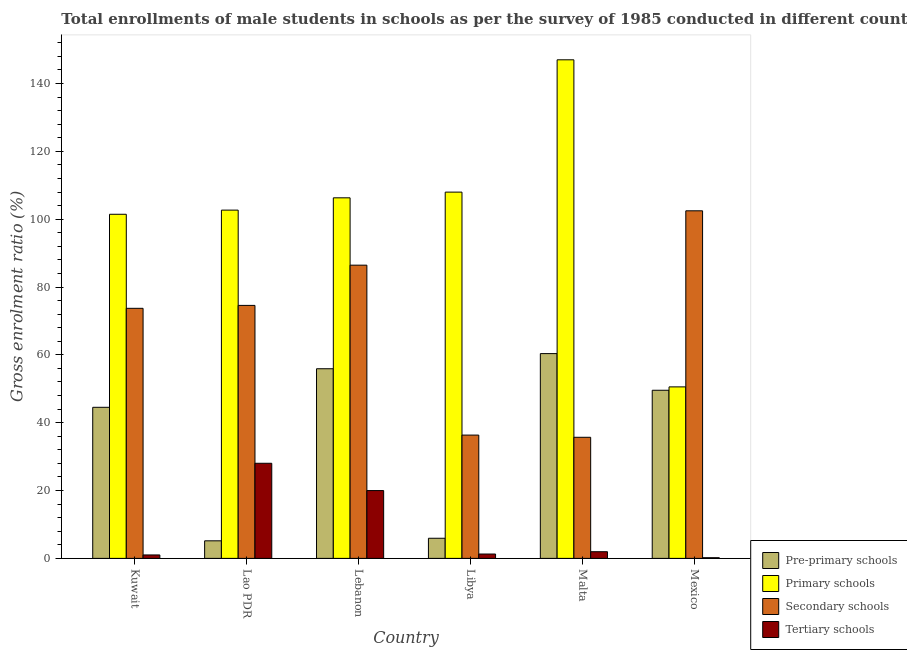Are the number of bars per tick equal to the number of legend labels?
Offer a terse response. Yes. How many bars are there on the 3rd tick from the left?
Your answer should be compact. 4. What is the label of the 2nd group of bars from the left?
Ensure brevity in your answer.  Lao PDR. What is the gross enrolment ratio(male) in primary schools in Mexico?
Ensure brevity in your answer.  50.56. Across all countries, what is the maximum gross enrolment ratio(male) in secondary schools?
Keep it short and to the point. 102.47. Across all countries, what is the minimum gross enrolment ratio(male) in primary schools?
Your answer should be compact. 50.56. In which country was the gross enrolment ratio(male) in pre-primary schools maximum?
Provide a succinct answer. Malta. What is the total gross enrolment ratio(male) in pre-primary schools in the graph?
Your answer should be compact. 221.49. What is the difference between the gross enrolment ratio(male) in secondary schools in Kuwait and that in Mexico?
Offer a terse response. -28.75. What is the difference between the gross enrolment ratio(male) in tertiary schools in Lao PDR and the gross enrolment ratio(male) in secondary schools in Kuwait?
Your answer should be very brief. -45.68. What is the average gross enrolment ratio(male) in pre-primary schools per country?
Provide a succinct answer. 36.91. What is the difference between the gross enrolment ratio(male) in tertiary schools and gross enrolment ratio(male) in secondary schools in Libya?
Your response must be concise. -35.06. In how many countries, is the gross enrolment ratio(male) in primary schools greater than 32 %?
Offer a terse response. 6. What is the ratio of the gross enrolment ratio(male) in secondary schools in Lebanon to that in Libya?
Offer a very short reply. 2.38. What is the difference between the highest and the second highest gross enrolment ratio(male) in secondary schools?
Your answer should be compact. 16.03. What is the difference between the highest and the lowest gross enrolment ratio(male) in secondary schools?
Offer a terse response. 66.77. In how many countries, is the gross enrolment ratio(male) in tertiary schools greater than the average gross enrolment ratio(male) in tertiary schools taken over all countries?
Make the answer very short. 2. Is the sum of the gross enrolment ratio(male) in secondary schools in Lao PDR and Mexico greater than the maximum gross enrolment ratio(male) in pre-primary schools across all countries?
Make the answer very short. Yes. What does the 2nd bar from the left in Lao PDR represents?
Your answer should be very brief. Primary schools. What does the 4th bar from the right in Mexico represents?
Make the answer very short. Pre-primary schools. Is it the case that in every country, the sum of the gross enrolment ratio(male) in pre-primary schools and gross enrolment ratio(male) in primary schools is greater than the gross enrolment ratio(male) in secondary schools?
Provide a short and direct response. No. How many bars are there?
Your answer should be very brief. 24. How many countries are there in the graph?
Give a very brief answer. 6. Are the values on the major ticks of Y-axis written in scientific E-notation?
Provide a succinct answer. No. Does the graph contain grids?
Make the answer very short. No. Where does the legend appear in the graph?
Provide a short and direct response. Bottom right. How many legend labels are there?
Ensure brevity in your answer.  4. What is the title of the graph?
Your answer should be very brief. Total enrollments of male students in schools as per the survey of 1985 conducted in different countries. What is the Gross enrolment ratio (%) in Pre-primary schools in Kuwait?
Your answer should be very brief. 44.54. What is the Gross enrolment ratio (%) of Primary schools in Kuwait?
Offer a very short reply. 101.44. What is the Gross enrolment ratio (%) of Secondary schools in Kuwait?
Offer a very short reply. 73.72. What is the Gross enrolment ratio (%) in Tertiary schools in Kuwait?
Your answer should be compact. 1.02. What is the Gross enrolment ratio (%) in Pre-primary schools in Lao PDR?
Offer a terse response. 5.18. What is the Gross enrolment ratio (%) of Primary schools in Lao PDR?
Offer a terse response. 102.67. What is the Gross enrolment ratio (%) in Secondary schools in Lao PDR?
Your answer should be very brief. 74.58. What is the Gross enrolment ratio (%) of Tertiary schools in Lao PDR?
Offer a terse response. 28.04. What is the Gross enrolment ratio (%) in Pre-primary schools in Lebanon?
Give a very brief answer. 55.91. What is the Gross enrolment ratio (%) of Primary schools in Lebanon?
Your answer should be compact. 106.29. What is the Gross enrolment ratio (%) in Secondary schools in Lebanon?
Ensure brevity in your answer.  86.44. What is the Gross enrolment ratio (%) in Tertiary schools in Lebanon?
Your answer should be compact. 19.99. What is the Gross enrolment ratio (%) in Pre-primary schools in Libya?
Provide a succinct answer. 5.93. What is the Gross enrolment ratio (%) in Primary schools in Libya?
Your answer should be very brief. 107.98. What is the Gross enrolment ratio (%) of Secondary schools in Libya?
Ensure brevity in your answer.  36.35. What is the Gross enrolment ratio (%) of Tertiary schools in Libya?
Your answer should be very brief. 1.28. What is the Gross enrolment ratio (%) of Pre-primary schools in Malta?
Ensure brevity in your answer.  60.37. What is the Gross enrolment ratio (%) of Primary schools in Malta?
Keep it short and to the point. 146.98. What is the Gross enrolment ratio (%) of Secondary schools in Malta?
Make the answer very short. 35.7. What is the Gross enrolment ratio (%) in Tertiary schools in Malta?
Provide a short and direct response. 1.97. What is the Gross enrolment ratio (%) in Pre-primary schools in Mexico?
Offer a terse response. 49.56. What is the Gross enrolment ratio (%) of Primary schools in Mexico?
Give a very brief answer. 50.56. What is the Gross enrolment ratio (%) of Secondary schools in Mexico?
Provide a short and direct response. 102.47. What is the Gross enrolment ratio (%) in Tertiary schools in Mexico?
Keep it short and to the point. 0.2. Across all countries, what is the maximum Gross enrolment ratio (%) in Pre-primary schools?
Your answer should be compact. 60.37. Across all countries, what is the maximum Gross enrolment ratio (%) of Primary schools?
Your response must be concise. 146.98. Across all countries, what is the maximum Gross enrolment ratio (%) of Secondary schools?
Offer a very short reply. 102.47. Across all countries, what is the maximum Gross enrolment ratio (%) of Tertiary schools?
Make the answer very short. 28.04. Across all countries, what is the minimum Gross enrolment ratio (%) of Pre-primary schools?
Make the answer very short. 5.18. Across all countries, what is the minimum Gross enrolment ratio (%) of Primary schools?
Give a very brief answer. 50.56. Across all countries, what is the minimum Gross enrolment ratio (%) in Secondary schools?
Make the answer very short. 35.7. Across all countries, what is the minimum Gross enrolment ratio (%) in Tertiary schools?
Your answer should be compact. 0.2. What is the total Gross enrolment ratio (%) of Pre-primary schools in the graph?
Ensure brevity in your answer.  221.49. What is the total Gross enrolment ratio (%) in Primary schools in the graph?
Provide a succinct answer. 615.92. What is the total Gross enrolment ratio (%) of Secondary schools in the graph?
Make the answer very short. 409.25. What is the total Gross enrolment ratio (%) in Tertiary schools in the graph?
Offer a terse response. 52.5. What is the difference between the Gross enrolment ratio (%) in Pre-primary schools in Kuwait and that in Lao PDR?
Provide a short and direct response. 39.36. What is the difference between the Gross enrolment ratio (%) in Primary schools in Kuwait and that in Lao PDR?
Offer a terse response. -1.23. What is the difference between the Gross enrolment ratio (%) in Secondary schools in Kuwait and that in Lao PDR?
Make the answer very short. -0.86. What is the difference between the Gross enrolment ratio (%) of Tertiary schools in Kuwait and that in Lao PDR?
Offer a terse response. -27.02. What is the difference between the Gross enrolment ratio (%) in Pre-primary schools in Kuwait and that in Lebanon?
Offer a terse response. -11.37. What is the difference between the Gross enrolment ratio (%) of Primary schools in Kuwait and that in Lebanon?
Ensure brevity in your answer.  -4.85. What is the difference between the Gross enrolment ratio (%) of Secondary schools in Kuwait and that in Lebanon?
Offer a terse response. -12.72. What is the difference between the Gross enrolment ratio (%) in Tertiary schools in Kuwait and that in Lebanon?
Offer a terse response. -18.98. What is the difference between the Gross enrolment ratio (%) in Pre-primary schools in Kuwait and that in Libya?
Provide a short and direct response. 38.61. What is the difference between the Gross enrolment ratio (%) of Primary schools in Kuwait and that in Libya?
Offer a terse response. -6.53. What is the difference between the Gross enrolment ratio (%) in Secondary schools in Kuwait and that in Libya?
Ensure brevity in your answer.  37.37. What is the difference between the Gross enrolment ratio (%) in Tertiary schools in Kuwait and that in Libya?
Offer a very short reply. -0.27. What is the difference between the Gross enrolment ratio (%) in Pre-primary schools in Kuwait and that in Malta?
Ensure brevity in your answer.  -15.83. What is the difference between the Gross enrolment ratio (%) in Primary schools in Kuwait and that in Malta?
Offer a terse response. -45.53. What is the difference between the Gross enrolment ratio (%) in Secondary schools in Kuwait and that in Malta?
Your response must be concise. 38.02. What is the difference between the Gross enrolment ratio (%) of Tertiary schools in Kuwait and that in Malta?
Your response must be concise. -0.95. What is the difference between the Gross enrolment ratio (%) in Pre-primary schools in Kuwait and that in Mexico?
Provide a succinct answer. -5.03. What is the difference between the Gross enrolment ratio (%) in Primary schools in Kuwait and that in Mexico?
Provide a succinct answer. 50.89. What is the difference between the Gross enrolment ratio (%) of Secondary schools in Kuwait and that in Mexico?
Provide a short and direct response. -28.75. What is the difference between the Gross enrolment ratio (%) in Tertiary schools in Kuwait and that in Mexico?
Ensure brevity in your answer.  0.82. What is the difference between the Gross enrolment ratio (%) of Pre-primary schools in Lao PDR and that in Lebanon?
Make the answer very short. -50.73. What is the difference between the Gross enrolment ratio (%) in Primary schools in Lao PDR and that in Lebanon?
Offer a terse response. -3.62. What is the difference between the Gross enrolment ratio (%) of Secondary schools in Lao PDR and that in Lebanon?
Your answer should be very brief. -11.86. What is the difference between the Gross enrolment ratio (%) of Tertiary schools in Lao PDR and that in Lebanon?
Offer a very short reply. 8.04. What is the difference between the Gross enrolment ratio (%) of Pre-primary schools in Lao PDR and that in Libya?
Provide a short and direct response. -0.75. What is the difference between the Gross enrolment ratio (%) of Primary schools in Lao PDR and that in Libya?
Your answer should be very brief. -5.3. What is the difference between the Gross enrolment ratio (%) of Secondary schools in Lao PDR and that in Libya?
Your answer should be compact. 38.23. What is the difference between the Gross enrolment ratio (%) in Tertiary schools in Lao PDR and that in Libya?
Provide a succinct answer. 26.75. What is the difference between the Gross enrolment ratio (%) of Pre-primary schools in Lao PDR and that in Malta?
Your answer should be compact. -55.19. What is the difference between the Gross enrolment ratio (%) in Primary schools in Lao PDR and that in Malta?
Make the answer very short. -44.31. What is the difference between the Gross enrolment ratio (%) in Secondary schools in Lao PDR and that in Malta?
Your answer should be compact. 38.88. What is the difference between the Gross enrolment ratio (%) in Tertiary schools in Lao PDR and that in Malta?
Provide a succinct answer. 26.07. What is the difference between the Gross enrolment ratio (%) in Pre-primary schools in Lao PDR and that in Mexico?
Give a very brief answer. -44.39. What is the difference between the Gross enrolment ratio (%) in Primary schools in Lao PDR and that in Mexico?
Your answer should be very brief. 52.11. What is the difference between the Gross enrolment ratio (%) of Secondary schools in Lao PDR and that in Mexico?
Give a very brief answer. -27.88. What is the difference between the Gross enrolment ratio (%) of Tertiary schools in Lao PDR and that in Mexico?
Your response must be concise. 27.84. What is the difference between the Gross enrolment ratio (%) of Pre-primary schools in Lebanon and that in Libya?
Provide a succinct answer. 49.97. What is the difference between the Gross enrolment ratio (%) in Primary schools in Lebanon and that in Libya?
Provide a short and direct response. -1.68. What is the difference between the Gross enrolment ratio (%) of Secondary schools in Lebanon and that in Libya?
Provide a succinct answer. 50.09. What is the difference between the Gross enrolment ratio (%) of Tertiary schools in Lebanon and that in Libya?
Your answer should be compact. 18.71. What is the difference between the Gross enrolment ratio (%) of Pre-primary schools in Lebanon and that in Malta?
Provide a short and direct response. -4.46. What is the difference between the Gross enrolment ratio (%) in Primary schools in Lebanon and that in Malta?
Your answer should be compact. -40.69. What is the difference between the Gross enrolment ratio (%) in Secondary schools in Lebanon and that in Malta?
Give a very brief answer. 50.74. What is the difference between the Gross enrolment ratio (%) in Tertiary schools in Lebanon and that in Malta?
Offer a terse response. 18.03. What is the difference between the Gross enrolment ratio (%) in Pre-primary schools in Lebanon and that in Mexico?
Your answer should be compact. 6.34. What is the difference between the Gross enrolment ratio (%) of Primary schools in Lebanon and that in Mexico?
Give a very brief answer. 55.73. What is the difference between the Gross enrolment ratio (%) of Secondary schools in Lebanon and that in Mexico?
Provide a succinct answer. -16.03. What is the difference between the Gross enrolment ratio (%) of Tertiary schools in Lebanon and that in Mexico?
Your answer should be very brief. 19.79. What is the difference between the Gross enrolment ratio (%) in Pre-primary schools in Libya and that in Malta?
Your response must be concise. -54.44. What is the difference between the Gross enrolment ratio (%) of Primary schools in Libya and that in Malta?
Keep it short and to the point. -39. What is the difference between the Gross enrolment ratio (%) of Secondary schools in Libya and that in Malta?
Make the answer very short. 0.65. What is the difference between the Gross enrolment ratio (%) of Tertiary schools in Libya and that in Malta?
Provide a succinct answer. -0.68. What is the difference between the Gross enrolment ratio (%) in Pre-primary schools in Libya and that in Mexico?
Your answer should be very brief. -43.63. What is the difference between the Gross enrolment ratio (%) in Primary schools in Libya and that in Mexico?
Give a very brief answer. 57.42. What is the difference between the Gross enrolment ratio (%) of Secondary schools in Libya and that in Mexico?
Your answer should be compact. -66.12. What is the difference between the Gross enrolment ratio (%) in Tertiary schools in Libya and that in Mexico?
Ensure brevity in your answer.  1.08. What is the difference between the Gross enrolment ratio (%) of Pre-primary schools in Malta and that in Mexico?
Provide a short and direct response. 10.81. What is the difference between the Gross enrolment ratio (%) of Primary schools in Malta and that in Mexico?
Give a very brief answer. 96.42. What is the difference between the Gross enrolment ratio (%) of Secondary schools in Malta and that in Mexico?
Your answer should be compact. -66.77. What is the difference between the Gross enrolment ratio (%) in Tertiary schools in Malta and that in Mexico?
Give a very brief answer. 1.77. What is the difference between the Gross enrolment ratio (%) in Pre-primary schools in Kuwait and the Gross enrolment ratio (%) in Primary schools in Lao PDR?
Ensure brevity in your answer.  -58.13. What is the difference between the Gross enrolment ratio (%) in Pre-primary schools in Kuwait and the Gross enrolment ratio (%) in Secondary schools in Lao PDR?
Offer a terse response. -30.04. What is the difference between the Gross enrolment ratio (%) of Pre-primary schools in Kuwait and the Gross enrolment ratio (%) of Tertiary schools in Lao PDR?
Offer a terse response. 16.5. What is the difference between the Gross enrolment ratio (%) in Primary schools in Kuwait and the Gross enrolment ratio (%) in Secondary schools in Lao PDR?
Offer a very short reply. 26.86. What is the difference between the Gross enrolment ratio (%) in Primary schools in Kuwait and the Gross enrolment ratio (%) in Tertiary schools in Lao PDR?
Ensure brevity in your answer.  73.41. What is the difference between the Gross enrolment ratio (%) of Secondary schools in Kuwait and the Gross enrolment ratio (%) of Tertiary schools in Lao PDR?
Ensure brevity in your answer.  45.68. What is the difference between the Gross enrolment ratio (%) in Pre-primary schools in Kuwait and the Gross enrolment ratio (%) in Primary schools in Lebanon?
Your response must be concise. -61.75. What is the difference between the Gross enrolment ratio (%) of Pre-primary schools in Kuwait and the Gross enrolment ratio (%) of Secondary schools in Lebanon?
Keep it short and to the point. -41.9. What is the difference between the Gross enrolment ratio (%) in Pre-primary schools in Kuwait and the Gross enrolment ratio (%) in Tertiary schools in Lebanon?
Ensure brevity in your answer.  24.54. What is the difference between the Gross enrolment ratio (%) of Primary schools in Kuwait and the Gross enrolment ratio (%) of Secondary schools in Lebanon?
Keep it short and to the point. 15.01. What is the difference between the Gross enrolment ratio (%) of Primary schools in Kuwait and the Gross enrolment ratio (%) of Tertiary schools in Lebanon?
Make the answer very short. 81.45. What is the difference between the Gross enrolment ratio (%) in Secondary schools in Kuwait and the Gross enrolment ratio (%) in Tertiary schools in Lebanon?
Your answer should be very brief. 53.72. What is the difference between the Gross enrolment ratio (%) of Pre-primary schools in Kuwait and the Gross enrolment ratio (%) of Primary schools in Libya?
Your response must be concise. -63.44. What is the difference between the Gross enrolment ratio (%) in Pre-primary schools in Kuwait and the Gross enrolment ratio (%) in Secondary schools in Libya?
Offer a terse response. 8.19. What is the difference between the Gross enrolment ratio (%) in Pre-primary schools in Kuwait and the Gross enrolment ratio (%) in Tertiary schools in Libya?
Your answer should be compact. 43.25. What is the difference between the Gross enrolment ratio (%) in Primary schools in Kuwait and the Gross enrolment ratio (%) in Secondary schools in Libya?
Ensure brevity in your answer.  65.1. What is the difference between the Gross enrolment ratio (%) in Primary schools in Kuwait and the Gross enrolment ratio (%) in Tertiary schools in Libya?
Give a very brief answer. 100.16. What is the difference between the Gross enrolment ratio (%) in Secondary schools in Kuwait and the Gross enrolment ratio (%) in Tertiary schools in Libya?
Ensure brevity in your answer.  72.43. What is the difference between the Gross enrolment ratio (%) of Pre-primary schools in Kuwait and the Gross enrolment ratio (%) of Primary schools in Malta?
Provide a short and direct response. -102.44. What is the difference between the Gross enrolment ratio (%) in Pre-primary schools in Kuwait and the Gross enrolment ratio (%) in Secondary schools in Malta?
Make the answer very short. 8.84. What is the difference between the Gross enrolment ratio (%) in Pre-primary schools in Kuwait and the Gross enrolment ratio (%) in Tertiary schools in Malta?
Keep it short and to the point. 42.57. What is the difference between the Gross enrolment ratio (%) in Primary schools in Kuwait and the Gross enrolment ratio (%) in Secondary schools in Malta?
Make the answer very short. 65.75. What is the difference between the Gross enrolment ratio (%) of Primary schools in Kuwait and the Gross enrolment ratio (%) of Tertiary schools in Malta?
Your response must be concise. 99.48. What is the difference between the Gross enrolment ratio (%) in Secondary schools in Kuwait and the Gross enrolment ratio (%) in Tertiary schools in Malta?
Provide a short and direct response. 71.75. What is the difference between the Gross enrolment ratio (%) of Pre-primary schools in Kuwait and the Gross enrolment ratio (%) of Primary schools in Mexico?
Offer a very short reply. -6.02. What is the difference between the Gross enrolment ratio (%) in Pre-primary schools in Kuwait and the Gross enrolment ratio (%) in Secondary schools in Mexico?
Offer a very short reply. -57.93. What is the difference between the Gross enrolment ratio (%) in Pre-primary schools in Kuwait and the Gross enrolment ratio (%) in Tertiary schools in Mexico?
Provide a short and direct response. 44.34. What is the difference between the Gross enrolment ratio (%) of Primary schools in Kuwait and the Gross enrolment ratio (%) of Secondary schools in Mexico?
Your answer should be compact. -1.02. What is the difference between the Gross enrolment ratio (%) of Primary schools in Kuwait and the Gross enrolment ratio (%) of Tertiary schools in Mexico?
Ensure brevity in your answer.  101.24. What is the difference between the Gross enrolment ratio (%) in Secondary schools in Kuwait and the Gross enrolment ratio (%) in Tertiary schools in Mexico?
Keep it short and to the point. 73.52. What is the difference between the Gross enrolment ratio (%) in Pre-primary schools in Lao PDR and the Gross enrolment ratio (%) in Primary schools in Lebanon?
Provide a short and direct response. -101.11. What is the difference between the Gross enrolment ratio (%) of Pre-primary schools in Lao PDR and the Gross enrolment ratio (%) of Secondary schools in Lebanon?
Your answer should be compact. -81.26. What is the difference between the Gross enrolment ratio (%) in Pre-primary schools in Lao PDR and the Gross enrolment ratio (%) in Tertiary schools in Lebanon?
Keep it short and to the point. -14.82. What is the difference between the Gross enrolment ratio (%) in Primary schools in Lao PDR and the Gross enrolment ratio (%) in Secondary schools in Lebanon?
Provide a short and direct response. 16.23. What is the difference between the Gross enrolment ratio (%) of Primary schools in Lao PDR and the Gross enrolment ratio (%) of Tertiary schools in Lebanon?
Provide a short and direct response. 82.68. What is the difference between the Gross enrolment ratio (%) of Secondary schools in Lao PDR and the Gross enrolment ratio (%) of Tertiary schools in Lebanon?
Provide a short and direct response. 54.59. What is the difference between the Gross enrolment ratio (%) of Pre-primary schools in Lao PDR and the Gross enrolment ratio (%) of Primary schools in Libya?
Keep it short and to the point. -102.8. What is the difference between the Gross enrolment ratio (%) of Pre-primary schools in Lao PDR and the Gross enrolment ratio (%) of Secondary schools in Libya?
Ensure brevity in your answer.  -31.17. What is the difference between the Gross enrolment ratio (%) in Pre-primary schools in Lao PDR and the Gross enrolment ratio (%) in Tertiary schools in Libya?
Your answer should be very brief. 3.89. What is the difference between the Gross enrolment ratio (%) of Primary schools in Lao PDR and the Gross enrolment ratio (%) of Secondary schools in Libya?
Keep it short and to the point. 66.32. What is the difference between the Gross enrolment ratio (%) in Primary schools in Lao PDR and the Gross enrolment ratio (%) in Tertiary schools in Libya?
Your response must be concise. 101.39. What is the difference between the Gross enrolment ratio (%) in Secondary schools in Lao PDR and the Gross enrolment ratio (%) in Tertiary schools in Libya?
Provide a succinct answer. 73.3. What is the difference between the Gross enrolment ratio (%) of Pre-primary schools in Lao PDR and the Gross enrolment ratio (%) of Primary schools in Malta?
Provide a short and direct response. -141.8. What is the difference between the Gross enrolment ratio (%) of Pre-primary schools in Lao PDR and the Gross enrolment ratio (%) of Secondary schools in Malta?
Ensure brevity in your answer.  -30.52. What is the difference between the Gross enrolment ratio (%) in Pre-primary schools in Lao PDR and the Gross enrolment ratio (%) in Tertiary schools in Malta?
Offer a very short reply. 3.21. What is the difference between the Gross enrolment ratio (%) of Primary schools in Lao PDR and the Gross enrolment ratio (%) of Secondary schools in Malta?
Offer a terse response. 66.97. What is the difference between the Gross enrolment ratio (%) of Primary schools in Lao PDR and the Gross enrolment ratio (%) of Tertiary schools in Malta?
Make the answer very short. 100.7. What is the difference between the Gross enrolment ratio (%) of Secondary schools in Lao PDR and the Gross enrolment ratio (%) of Tertiary schools in Malta?
Provide a succinct answer. 72.61. What is the difference between the Gross enrolment ratio (%) in Pre-primary schools in Lao PDR and the Gross enrolment ratio (%) in Primary schools in Mexico?
Your response must be concise. -45.38. What is the difference between the Gross enrolment ratio (%) of Pre-primary schools in Lao PDR and the Gross enrolment ratio (%) of Secondary schools in Mexico?
Offer a terse response. -97.29. What is the difference between the Gross enrolment ratio (%) in Pre-primary schools in Lao PDR and the Gross enrolment ratio (%) in Tertiary schools in Mexico?
Offer a terse response. 4.98. What is the difference between the Gross enrolment ratio (%) of Primary schools in Lao PDR and the Gross enrolment ratio (%) of Secondary schools in Mexico?
Your response must be concise. 0.2. What is the difference between the Gross enrolment ratio (%) in Primary schools in Lao PDR and the Gross enrolment ratio (%) in Tertiary schools in Mexico?
Give a very brief answer. 102.47. What is the difference between the Gross enrolment ratio (%) in Secondary schools in Lao PDR and the Gross enrolment ratio (%) in Tertiary schools in Mexico?
Your response must be concise. 74.38. What is the difference between the Gross enrolment ratio (%) of Pre-primary schools in Lebanon and the Gross enrolment ratio (%) of Primary schools in Libya?
Your response must be concise. -52.07. What is the difference between the Gross enrolment ratio (%) of Pre-primary schools in Lebanon and the Gross enrolment ratio (%) of Secondary schools in Libya?
Your answer should be very brief. 19.56. What is the difference between the Gross enrolment ratio (%) in Pre-primary schools in Lebanon and the Gross enrolment ratio (%) in Tertiary schools in Libya?
Your answer should be very brief. 54.62. What is the difference between the Gross enrolment ratio (%) in Primary schools in Lebanon and the Gross enrolment ratio (%) in Secondary schools in Libya?
Ensure brevity in your answer.  69.94. What is the difference between the Gross enrolment ratio (%) in Primary schools in Lebanon and the Gross enrolment ratio (%) in Tertiary schools in Libya?
Provide a succinct answer. 105.01. What is the difference between the Gross enrolment ratio (%) of Secondary schools in Lebanon and the Gross enrolment ratio (%) of Tertiary schools in Libya?
Make the answer very short. 85.15. What is the difference between the Gross enrolment ratio (%) of Pre-primary schools in Lebanon and the Gross enrolment ratio (%) of Primary schools in Malta?
Ensure brevity in your answer.  -91.07. What is the difference between the Gross enrolment ratio (%) in Pre-primary schools in Lebanon and the Gross enrolment ratio (%) in Secondary schools in Malta?
Keep it short and to the point. 20.21. What is the difference between the Gross enrolment ratio (%) in Pre-primary schools in Lebanon and the Gross enrolment ratio (%) in Tertiary schools in Malta?
Your answer should be compact. 53.94. What is the difference between the Gross enrolment ratio (%) of Primary schools in Lebanon and the Gross enrolment ratio (%) of Secondary schools in Malta?
Your answer should be very brief. 70.59. What is the difference between the Gross enrolment ratio (%) in Primary schools in Lebanon and the Gross enrolment ratio (%) in Tertiary schools in Malta?
Give a very brief answer. 104.32. What is the difference between the Gross enrolment ratio (%) of Secondary schools in Lebanon and the Gross enrolment ratio (%) of Tertiary schools in Malta?
Your answer should be very brief. 84.47. What is the difference between the Gross enrolment ratio (%) in Pre-primary schools in Lebanon and the Gross enrolment ratio (%) in Primary schools in Mexico?
Make the answer very short. 5.35. What is the difference between the Gross enrolment ratio (%) in Pre-primary schools in Lebanon and the Gross enrolment ratio (%) in Secondary schools in Mexico?
Offer a terse response. -46.56. What is the difference between the Gross enrolment ratio (%) in Pre-primary schools in Lebanon and the Gross enrolment ratio (%) in Tertiary schools in Mexico?
Your response must be concise. 55.71. What is the difference between the Gross enrolment ratio (%) of Primary schools in Lebanon and the Gross enrolment ratio (%) of Secondary schools in Mexico?
Your response must be concise. 3.83. What is the difference between the Gross enrolment ratio (%) in Primary schools in Lebanon and the Gross enrolment ratio (%) in Tertiary schools in Mexico?
Offer a very short reply. 106.09. What is the difference between the Gross enrolment ratio (%) of Secondary schools in Lebanon and the Gross enrolment ratio (%) of Tertiary schools in Mexico?
Offer a very short reply. 86.24. What is the difference between the Gross enrolment ratio (%) of Pre-primary schools in Libya and the Gross enrolment ratio (%) of Primary schools in Malta?
Offer a very short reply. -141.05. What is the difference between the Gross enrolment ratio (%) in Pre-primary schools in Libya and the Gross enrolment ratio (%) in Secondary schools in Malta?
Your answer should be very brief. -29.77. What is the difference between the Gross enrolment ratio (%) of Pre-primary schools in Libya and the Gross enrolment ratio (%) of Tertiary schools in Malta?
Keep it short and to the point. 3.97. What is the difference between the Gross enrolment ratio (%) in Primary schools in Libya and the Gross enrolment ratio (%) in Secondary schools in Malta?
Give a very brief answer. 72.28. What is the difference between the Gross enrolment ratio (%) of Primary schools in Libya and the Gross enrolment ratio (%) of Tertiary schools in Malta?
Provide a short and direct response. 106.01. What is the difference between the Gross enrolment ratio (%) of Secondary schools in Libya and the Gross enrolment ratio (%) of Tertiary schools in Malta?
Offer a very short reply. 34.38. What is the difference between the Gross enrolment ratio (%) in Pre-primary schools in Libya and the Gross enrolment ratio (%) in Primary schools in Mexico?
Ensure brevity in your answer.  -44.62. What is the difference between the Gross enrolment ratio (%) in Pre-primary schools in Libya and the Gross enrolment ratio (%) in Secondary schools in Mexico?
Your answer should be very brief. -96.53. What is the difference between the Gross enrolment ratio (%) in Pre-primary schools in Libya and the Gross enrolment ratio (%) in Tertiary schools in Mexico?
Ensure brevity in your answer.  5.73. What is the difference between the Gross enrolment ratio (%) of Primary schools in Libya and the Gross enrolment ratio (%) of Secondary schools in Mexico?
Offer a very short reply. 5.51. What is the difference between the Gross enrolment ratio (%) of Primary schools in Libya and the Gross enrolment ratio (%) of Tertiary schools in Mexico?
Provide a short and direct response. 107.78. What is the difference between the Gross enrolment ratio (%) in Secondary schools in Libya and the Gross enrolment ratio (%) in Tertiary schools in Mexico?
Offer a terse response. 36.15. What is the difference between the Gross enrolment ratio (%) in Pre-primary schools in Malta and the Gross enrolment ratio (%) in Primary schools in Mexico?
Your response must be concise. 9.81. What is the difference between the Gross enrolment ratio (%) of Pre-primary schools in Malta and the Gross enrolment ratio (%) of Secondary schools in Mexico?
Offer a very short reply. -42.1. What is the difference between the Gross enrolment ratio (%) of Pre-primary schools in Malta and the Gross enrolment ratio (%) of Tertiary schools in Mexico?
Keep it short and to the point. 60.17. What is the difference between the Gross enrolment ratio (%) of Primary schools in Malta and the Gross enrolment ratio (%) of Secondary schools in Mexico?
Make the answer very short. 44.51. What is the difference between the Gross enrolment ratio (%) of Primary schools in Malta and the Gross enrolment ratio (%) of Tertiary schools in Mexico?
Your answer should be compact. 146.78. What is the difference between the Gross enrolment ratio (%) of Secondary schools in Malta and the Gross enrolment ratio (%) of Tertiary schools in Mexico?
Offer a very short reply. 35.5. What is the average Gross enrolment ratio (%) of Pre-primary schools per country?
Provide a short and direct response. 36.91. What is the average Gross enrolment ratio (%) of Primary schools per country?
Your response must be concise. 102.65. What is the average Gross enrolment ratio (%) of Secondary schools per country?
Keep it short and to the point. 68.21. What is the average Gross enrolment ratio (%) in Tertiary schools per country?
Keep it short and to the point. 8.75. What is the difference between the Gross enrolment ratio (%) in Pre-primary schools and Gross enrolment ratio (%) in Primary schools in Kuwait?
Your answer should be very brief. -56.91. What is the difference between the Gross enrolment ratio (%) of Pre-primary schools and Gross enrolment ratio (%) of Secondary schools in Kuwait?
Your response must be concise. -29.18. What is the difference between the Gross enrolment ratio (%) of Pre-primary schools and Gross enrolment ratio (%) of Tertiary schools in Kuwait?
Offer a very short reply. 43.52. What is the difference between the Gross enrolment ratio (%) of Primary schools and Gross enrolment ratio (%) of Secondary schools in Kuwait?
Provide a succinct answer. 27.73. What is the difference between the Gross enrolment ratio (%) in Primary schools and Gross enrolment ratio (%) in Tertiary schools in Kuwait?
Ensure brevity in your answer.  100.43. What is the difference between the Gross enrolment ratio (%) in Secondary schools and Gross enrolment ratio (%) in Tertiary schools in Kuwait?
Ensure brevity in your answer.  72.7. What is the difference between the Gross enrolment ratio (%) of Pre-primary schools and Gross enrolment ratio (%) of Primary schools in Lao PDR?
Make the answer very short. -97.49. What is the difference between the Gross enrolment ratio (%) of Pre-primary schools and Gross enrolment ratio (%) of Secondary schools in Lao PDR?
Your response must be concise. -69.4. What is the difference between the Gross enrolment ratio (%) in Pre-primary schools and Gross enrolment ratio (%) in Tertiary schools in Lao PDR?
Ensure brevity in your answer.  -22.86. What is the difference between the Gross enrolment ratio (%) in Primary schools and Gross enrolment ratio (%) in Secondary schools in Lao PDR?
Offer a terse response. 28.09. What is the difference between the Gross enrolment ratio (%) of Primary schools and Gross enrolment ratio (%) of Tertiary schools in Lao PDR?
Provide a short and direct response. 74.63. What is the difference between the Gross enrolment ratio (%) in Secondary schools and Gross enrolment ratio (%) in Tertiary schools in Lao PDR?
Offer a very short reply. 46.54. What is the difference between the Gross enrolment ratio (%) of Pre-primary schools and Gross enrolment ratio (%) of Primary schools in Lebanon?
Your answer should be very brief. -50.39. What is the difference between the Gross enrolment ratio (%) of Pre-primary schools and Gross enrolment ratio (%) of Secondary schools in Lebanon?
Your answer should be compact. -30.53. What is the difference between the Gross enrolment ratio (%) of Pre-primary schools and Gross enrolment ratio (%) of Tertiary schools in Lebanon?
Provide a short and direct response. 35.91. What is the difference between the Gross enrolment ratio (%) in Primary schools and Gross enrolment ratio (%) in Secondary schools in Lebanon?
Your answer should be very brief. 19.85. What is the difference between the Gross enrolment ratio (%) in Primary schools and Gross enrolment ratio (%) in Tertiary schools in Lebanon?
Give a very brief answer. 86.3. What is the difference between the Gross enrolment ratio (%) in Secondary schools and Gross enrolment ratio (%) in Tertiary schools in Lebanon?
Make the answer very short. 66.45. What is the difference between the Gross enrolment ratio (%) of Pre-primary schools and Gross enrolment ratio (%) of Primary schools in Libya?
Keep it short and to the point. -102.04. What is the difference between the Gross enrolment ratio (%) of Pre-primary schools and Gross enrolment ratio (%) of Secondary schools in Libya?
Provide a short and direct response. -30.42. What is the difference between the Gross enrolment ratio (%) in Pre-primary schools and Gross enrolment ratio (%) in Tertiary schools in Libya?
Give a very brief answer. 4.65. What is the difference between the Gross enrolment ratio (%) of Primary schools and Gross enrolment ratio (%) of Secondary schools in Libya?
Offer a very short reply. 71.63. What is the difference between the Gross enrolment ratio (%) of Primary schools and Gross enrolment ratio (%) of Tertiary schools in Libya?
Your answer should be very brief. 106.69. What is the difference between the Gross enrolment ratio (%) in Secondary schools and Gross enrolment ratio (%) in Tertiary schools in Libya?
Your answer should be very brief. 35.06. What is the difference between the Gross enrolment ratio (%) of Pre-primary schools and Gross enrolment ratio (%) of Primary schools in Malta?
Make the answer very short. -86.61. What is the difference between the Gross enrolment ratio (%) in Pre-primary schools and Gross enrolment ratio (%) in Secondary schools in Malta?
Your response must be concise. 24.67. What is the difference between the Gross enrolment ratio (%) in Pre-primary schools and Gross enrolment ratio (%) in Tertiary schools in Malta?
Make the answer very short. 58.4. What is the difference between the Gross enrolment ratio (%) of Primary schools and Gross enrolment ratio (%) of Secondary schools in Malta?
Provide a short and direct response. 111.28. What is the difference between the Gross enrolment ratio (%) in Primary schools and Gross enrolment ratio (%) in Tertiary schools in Malta?
Offer a very short reply. 145.01. What is the difference between the Gross enrolment ratio (%) in Secondary schools and Gross enrolment ratio (%) in Tertiary schools in Malta?
Ensure brevity in your answer.  33.73. What is the difference between the Gross enrolment ratio (%) of Pre-primary schools and Gross enrolment ratio (%) of Primary schools in Mexico?
Offer a very short reply. -0.99. What is the difference between the Gross enrolment ratio (%) of Pre-primary schools and Gross enrolment ratio (%) of Secondary schools in Mexico?
Your response must be concise. -52.9. What is the difference between the Gross enrolment ratio (%) of Pre-primary schools and Gross enrolment ratio (%) of Tertiary schools in Mexico?
Your answer should be compact. 49.36. What is the difference between the Gross enrolment ratio (%) of Primary schools and Gross enrolment ratio (%) of Secondary schools in Mexico?
Offer a terse response. -51.91. What is the difference between the Gross enrolment ratio (%) of Primary schools and Gross enrolment ratio (%) of Tertiary schools in Mexico?
Keep it short and to the point. 50.36. What is the difference between the Gross enrolment ratio (%) in Secondary schools and Gross enrolment ratio (%) in Tertiary schools in Mexico?
Offer a terse response. 102.27. What is the ratio of the Gross enrolment ratio (%) in Pre-primary schools in Kuwait to that in Lao PDR?
Provide a short and direct response. 8.6. What is the ratio of the Gross enrolment ratio (%) in Secondary schools in Kuwait to that in Lao PDR?
Offer a terse response. 0.99. What is the ratio of the Gross enrolment ratio (%) in Tertiary schools in Kuwait to that in Lao PDR?
Provide a short and direct response. 0.04. What is the ratio of the Gross enrolment ratio (%) in Pre-primary schools in Kuwait to that in Lebanon?
Give a very brief answer. 0.8. What is the ratio of the Gross enrolment ratio (%) of Primary schools in Kuwait to that in Lebanon?
Give a very brief answer. 0.95. What is the ratio of the Gross enrolment ratio (%) of Secondary schools in Kuwait to that in Lebanon?
Provide a succinct answer. 0.85. What is the ratio of the Gross enrolment ratio (%) in Tertiary schools in Kuwait to that in Lebanon?
Give a very brief answer. 0.05. What is the ratio of the Gross enrolment ratio (%) of Pre-primary schools in Kuwait to that in Libya?
Your response must be concise. 7.51. What is the ratio of the Gross enrolment ratio (%) of Primary schools in Kuwait to that in Libya?
Offer a very short reply. 0.94. What is the ratio of the Gross enrolment ratio (%) of Secondary schools in Kuwait to that in Libya?
Offer a very short reply. 2.03. What is the ratio of the Gross enrolment ratio (%) of Tertiary schools in Kuwait to that in Libya?
Offer a terse response. 0.79. What is the ratio of the Gross enrolment ratio (%) in Pre-primary schools in Kuwait to that in Malta?
Make the answer very short. 0.74. What is the ratio of the Gross enrolment ratio (%) of Primary schools in Kuwait to that in Malta?
Give a very brief answer. 0.69. What is the ratio of the Gross enrolment ratio (%) in Secondary schools in Kuwait to that in Malta?
Offer a terse response. 2.06. What is the ratio of the Gross enrolment ratio (%) in Tertiary schools in Kuwait to that in Malta?
Your answer should be very brief. 0.52. What is the ratio of the Gross enrolment ratio (%) of Pre-primary schools in Kuwait to that in Mexico?
Your answer should be compact. 0.9. What is the ratio of the Gross enrolment ratio (%) in Primary schools in Kuwait to that in Mexico?
Offer a terse response. 2.01. What is the ratio of the Gross enrolment ratio (%) in Secondary schools in Kuwait to that in Mexico?
Offer a very short reply. 0.72. What is the ratio of the Gross enrolment ratio (%) in Tertiary schools in Kuwait to that in Mexico?
Your answer should be compact. 5.08. What is the ratio of the Gross enrolment ratio (%) in Pre-primary schools in Lao PDR to that in Lebanon?
Provide a short and direct response. 0.09. What is the ratio of the Gross enrolment ratio (%) of Primary schools in Lao PDR to that in Lebanon?
Offer a terse response. 0.97. What is the ratio of the Gross enrolment ratio (%) in Secondary schools in Lao PDR to that in Lebanon?
Make the answer very short. 0.86. What is the ratio of the Gross enrolment ratio (%) of Tertiary schools in Lao PDR to that in Lebanon?
Provide a short and direct response. 1.4. What is the ratio of the Gross enrolment ratio (%) of Pre-primary schools in Lao PDR to that in Libya?
Offer a very short reply. 0.87. What is the ratio of the Gross enrolment ratio (%) of Primary schools in Lao PDR to that in Libya?
Your answer should be very brief. 0.95. What is the ratio of the Gross enrolment ratio (%) of Secondary schools in Lao PDR to that in Libya?
Ensure brevity in your answer.  2.05. What is the ratio of the Gross enrolment ratio (%) of Tertiary schools in Lao PDR to that in Libya?
Make the answer very short. 21.82. What is the ratio of the Gross enrolment ratio (%) of Pre-primary schools in Lao PDR to that in Malta?
Your response must be concise. 0.09. What is the ratio of the Gross enrolment ratio (%) of Primary schools in Lao PDR to that in Malta?
Offer a very short reply. 0.7. What is the ratio of the Gross enrolment ratio (%) in Secondary schools in Lao PDR to that in Malta?
Ensure brevity in your answer.  2.09. What is the ratio of the Gross enrolment ratio (%) of Tertiary schools in Lao PDR to that in Malta?
Your answer should be very brief. 14.26. What is the ratio of the Gross enrolment ratio (%) in Pre-primary schools in Lao PDR to that in Mexico?
Your response must be concise. 0.1. What is the ratio of the Gross enrolment ratio (%) in Primary schools in Lao PDR to that in Mexico?
Offer a very short reply. 2.03. What is the ratio of the Gross enrolment ratio (%) of Secondary schools in Lao PDR to that in Mexico?
Keep it short and to the point. 0.73. What is the ratio of the Gross enrolment ratio (%) of Tertiary schools in Lao PDR to that in Mexico?
Keep it short and to the point. 140.11. What is the ratio of the Gross enrolment ratio (%) in Pre-primary schools in Lebanon to that in Libya?
Offer a very short reply. 9.42. What is the ratio of the Gross enrolment ratio (%) of Primary schools in Lebanon to that in Libya?
Give a very brief answer. 0.98. What is the ratio of the Gross enrolment ratio (%) in Secondary schools in Lebanon to that in Libya?
Your response must be concise. 2.38. What is the ratio of the Gross enrolment ratio (%) of Tertiary schools in Lebanon to that in Libya?
Provide a short and direct response. 15.56. What is the ratio of the Gross enrolment ratio (%) of Pre-primary schools in Lebanon to that in Malta?
Your response must be concise. 0.93. What is the ratio of the Gross enrolment ratio (%) in Primary schools in Lebanon to that in Malta?
Give a very brief answer. 0.72. What is the ratio of the Gross enrolment ratio (%) of Secondary schools in Lebanon to that in Malta?
Offer a very short reply. 2.42. What is the ratio of the Gross enrolment ratio (%) in Tertiary schools in Lebanon to that in Malta?
Ensure brevity in your answer.  10.17. What is the ratio of the Gross enrolment ratio (%) of Pre-primary schools in Lebanon to that in Mexico?
Offer a very short reply. 1.13. What is the ratio of the Gross enrolment ratio (%) of Primary schools in Lebanon to that in Mexico?
Provide a short and direct response. 2.1. What is the ratio of the Gross enrolment ratio (%) of Secondary schools in Lebanon to that in Mexico?
Make the answer very short. 0.84. What is the ratio of the Gross enrolment ratio (%) in Tertiary schools in Lebanon to that in Mexico?
Give a very brief answer. 99.91. What is the ratio of the Gross enrolment ratio (%) of Pre-primary schools in Libya to that in Malta?
Your response must be concise. 0.1. What is the ratio of the Gross enrolment ratio (%) of Primary schools in Libya to that in Malta?
Ensure brevity in your answer.  0.73. What is the ratio of the Gross enrolment ratio (%) in Secondary schools in Libya to that in Malta?
Provide a succinct answer. 1.02. What is the ratio of the Gross enrolment ratio (%) in Tertiary schools in Libya to that in Malta?
Give a very brief answer. 0.65. What is the ratio of the Gross enrolment ratio (%) in Pre-primary schools in Libya to that in Mexico?
Ensure brevity in your answer.  0.12. What is the ratio of the Gross enrolment ratio (%) in Primary schools in Libya to that in Mexico?
Ensure brevity in your answer.  2.14. What is the ratio of the Gross enrolment ratio (%) of Secondary schools in Libya to that in Mexico?
Offer a terse response. 0.35. What is the ratio of the Gross enrolment ratio (%) in Tertiary schools in Libya to that in Mexico?
Keep it short and to the point. 6.42. What is the ratio of the Gross enrolment ratio (%) in Pre-primary schools in Malta to that in Mexico?
Provide a short and direct response. 1.22. What is the ratio of the Gross enrolment ratio (%) in Primary schools in Malta to that in Mexico?
Give a very brief answer. 2.91. What is the ratio of the Gross enrolment ratio (%) in Secondary schools in Malta to that in Mexico?
Offer a terse response. 0.35. What is the ratio of the Gross enrolment ratio (%) of Tertiary schools in Malta to that in Mexico?
Offer a very short reply. 9.83. What is the difference between the highest and the second highest Gross enrolment ratio (%) of Pre-primary schools?
Provide a short and direct response. 4.46. What is the difference between the highest and the second highest Gross enrolment ratio (%) of Primary schools?
Keep it short and to the point. 39. What is the difference between the highest and the second highest Gross enrolment ratio (%) in Secondary schools?
Your response must be concise. 16.03. What is the difference between the highest and the second highest Gross enrolment ratio (%) in Tertiary schools?
Give a very brief answer. 8.04. What is the difference between the highest and the lowest Gross enrolment ratio (%) of Pre-primary schools?
Give a very brief answer. 55.19. What is the difference between the highest and the lowest Gross enrolment ratio (%) of Primary schools?
Make the answer very short. 96.42. What is the difference between the highest and the lowest Gross enrolment ratio (%) in Secondary schools?
Your response must be concise. 66.77. What is the difference between the highest and the lowest Gross enrolment ratio (%) in Tertiary schools?
Make the answer very short. 27.84. 